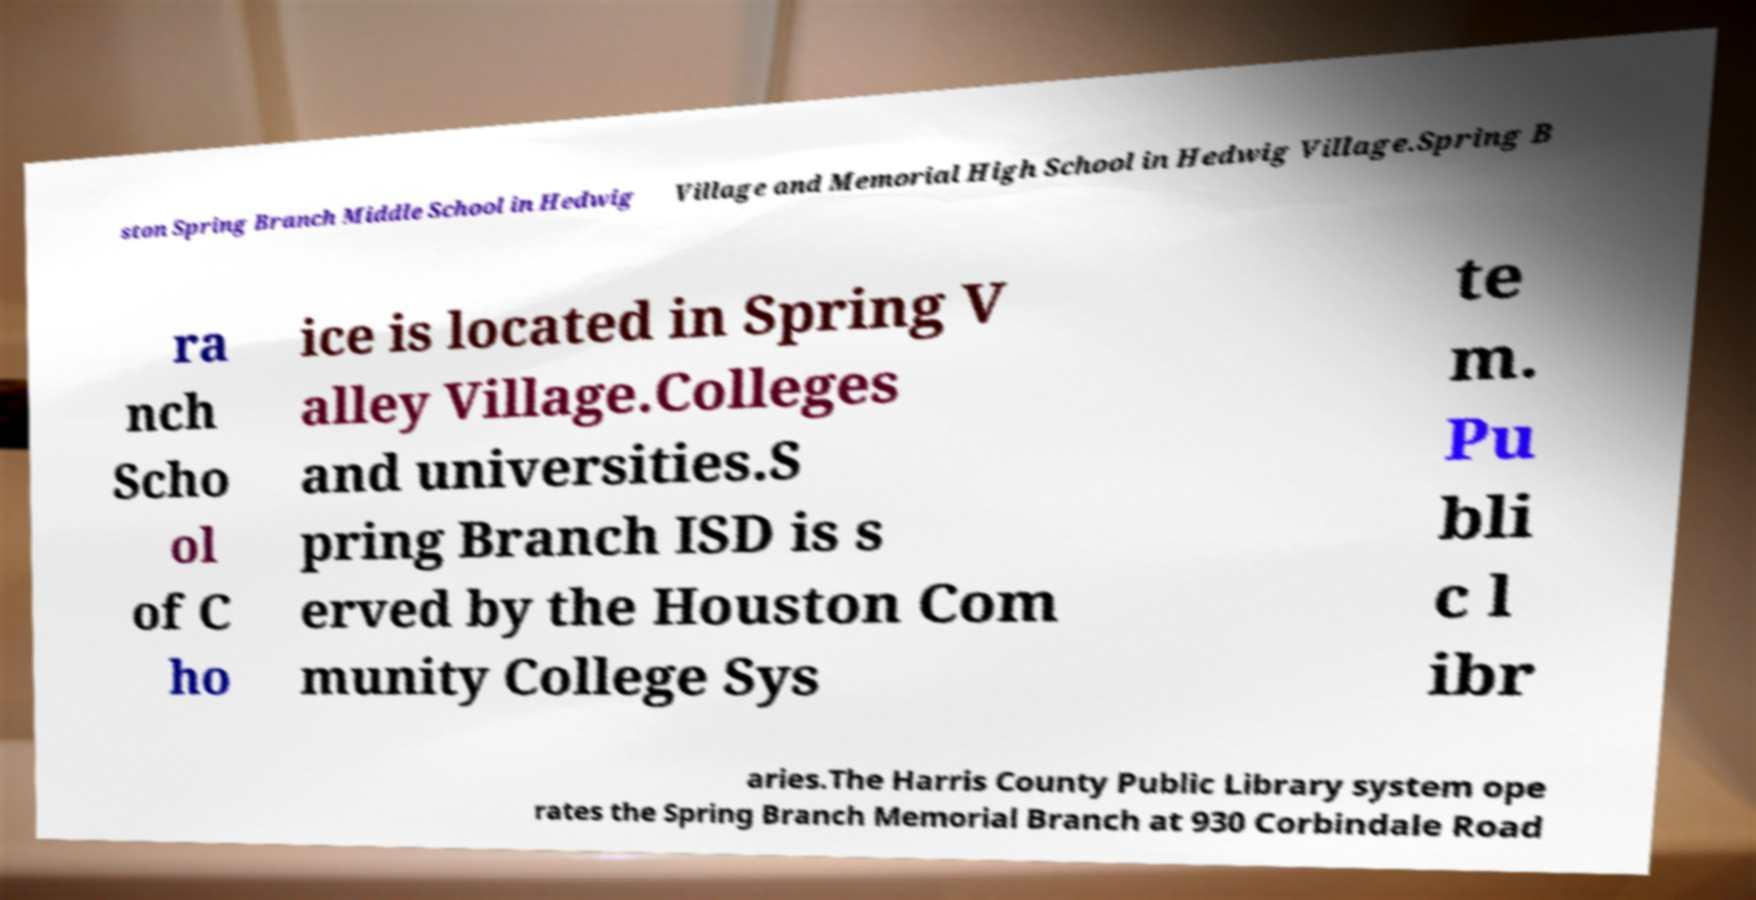Could you extract and type out the text from this image? ston Spring Branch Middle School in Hedwig Village and Memorial High School in Hedwig Village.Spring B ra nch Scho ol of C ho ice is located in Spring V alley Village.Colleges and universities.S pring Branch ISD is s erved by the Houston Com munity College Sys te m. Pu bli c l ibr aries.The Harris County Public Library system ope rates the Spring Branch Memorial Branch at 930 Corbindale Road 